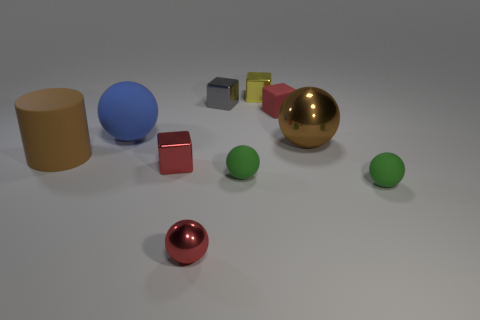Subtract all brown spheres. How many spheres are left? 4 Subtract all big blue matte balls. How many balls are left? 4 Subtract all cyan spheres. Subtract all brown blocks. How many spheres are left? 5 Subtract all cylinders. How many objects are left? 9 Subtract 0 red cylinders. How many objects are left? 10 Subtract all yellow rubber balls. Subtract all small green rubber spheres. How many objects are left? 8 Add 5 tiny yellow shiny cubes. How many tiny yellow shiny cubes are left? 6 Add 4 metallic cylinders. How many metallic cylinders exist? 4 